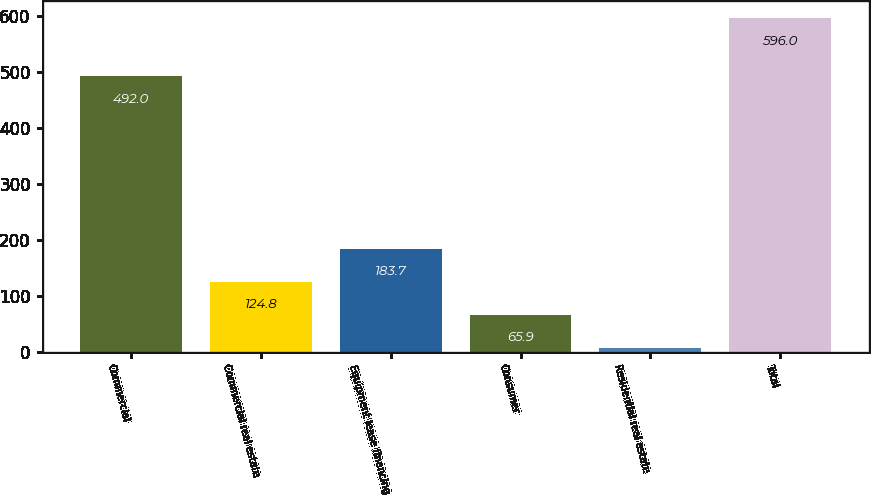<chart> <loc_0><loc_0><loc_500><loc_500><bar_chart><fcel>Commercial<fcel>Commercial real estate<fcel>Equipment lease financing<fcel>Consumer<fcel>Residential real estate<fcel>Total<nl><fcel>492<fcel>124.8<fcel>183.7<fcel>65.9<fcel>7<fcel>596<nl></chart> 